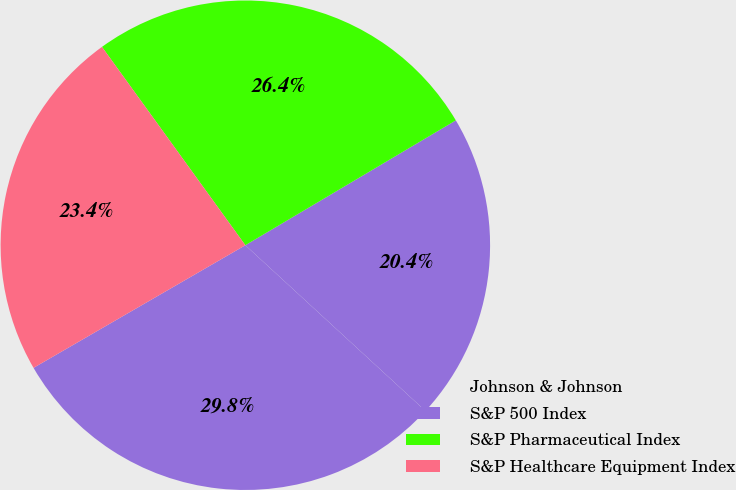Convert chart to OTSL. <chart><loc_0><loc_0><loc_500><loc_500><pie_chart><fcel>Johnson & Johnson<fcel>S&P 500 Index<fcel>S&P Pharmaceutical Index<fcel>S&P Healthcare Equipment Index<nl><fcel>29.81%<fcel>20.36%<fcel>26.44%<fcel>23.39%<nl></chart> 